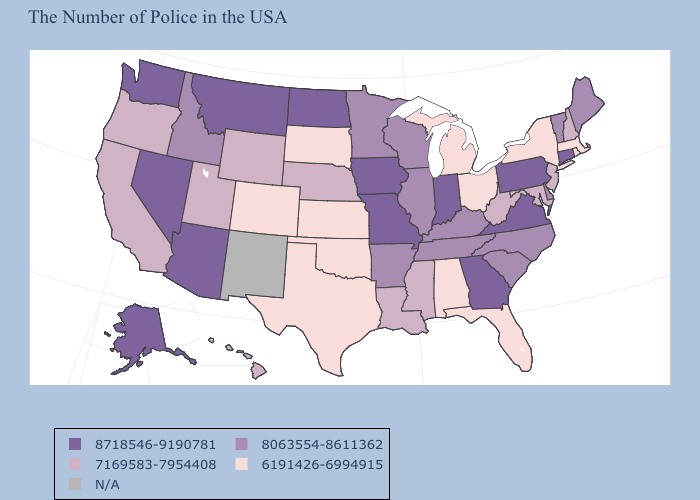Does Rhode Island have the highest value in the USA?
Be succinct. No. Name the states that have a value in the range 7169583-7954408?
Keep it brief. New Hampshire, New Jersey, Maryland, West Virginia, Mississippi, Louisiana, Nebraska, Wyoming, Utah, California, Oregon, Hawaii. What is the lowest value in the USA?
Give a very brief answer. 6191426-6994915. Name the states that have a value in the range 8063554-8611362?
Answer briefly. Maine, Vermont, Delaware, North Carolina, South Carolina, Kentucky, Tennessee, Wisconsin, Illinois, Arkansas, Minnesota, Idaho. Which states hav the highest value in the South?
Concise answer only. Virginia, Georgia. What is the value of Nebraska?
Write a very short answer. 7169583-7954408. Name the states that have a value in the range 8718546-9190781?
Give a very brief answer. Connecticut, Pennsylvania, Virginia, Georgia, Indiana, Missouri, Iowa, North Dakota, Montana, Arizona, Nevada, Washington, Alaska. What is the highest value in states that border Montana?
Be succinct. 8718546-9190781. Among the states that border Arizona , which have the highest value?
Answer briefly. Nevada. Name the states that have a value in the range N/A?
Give a very brief answer. New Mexico. Name the states that have a value in the range 8063554-8611362?
Concise answer only. Maine, Vermont, Delaware, North Carolina, South Carolina, Kentucky, Tennessee, Wisconsin, Illinois, Arkansas, Minnesota, Idaho. Which states hav the highest value in the South?
Quick response, please. Virginia, Georgia. Name the states that have a value in the range 8063554-8611362?
Write a very short answer. Maine, Vermont, Delaware, North Carolina, South Carolina, Kentucky, Tennessee, Wisconsin, Illinois, Arkansas, Minnesota, Idaho. What is the lowest value in the MidWest?
Keep it brief. 6191426-6994915. 